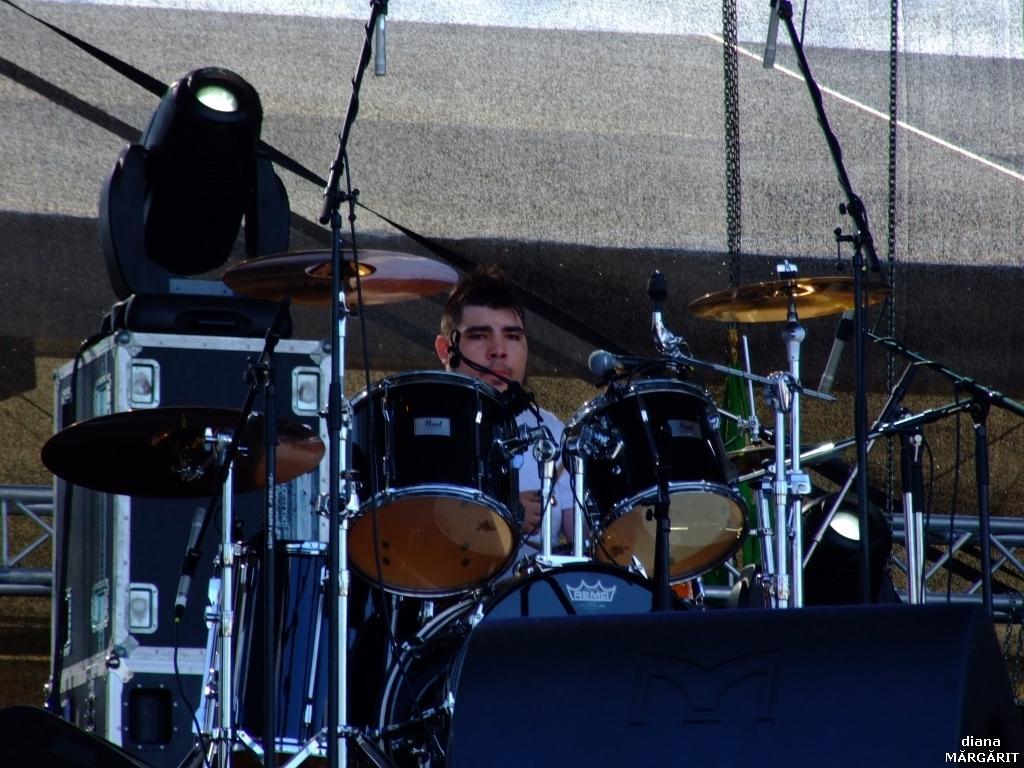Please provide a concise description of this image. In this image we can see a person playing drums, there are some musical instruments like, speakers, mics, stands and other objects. 